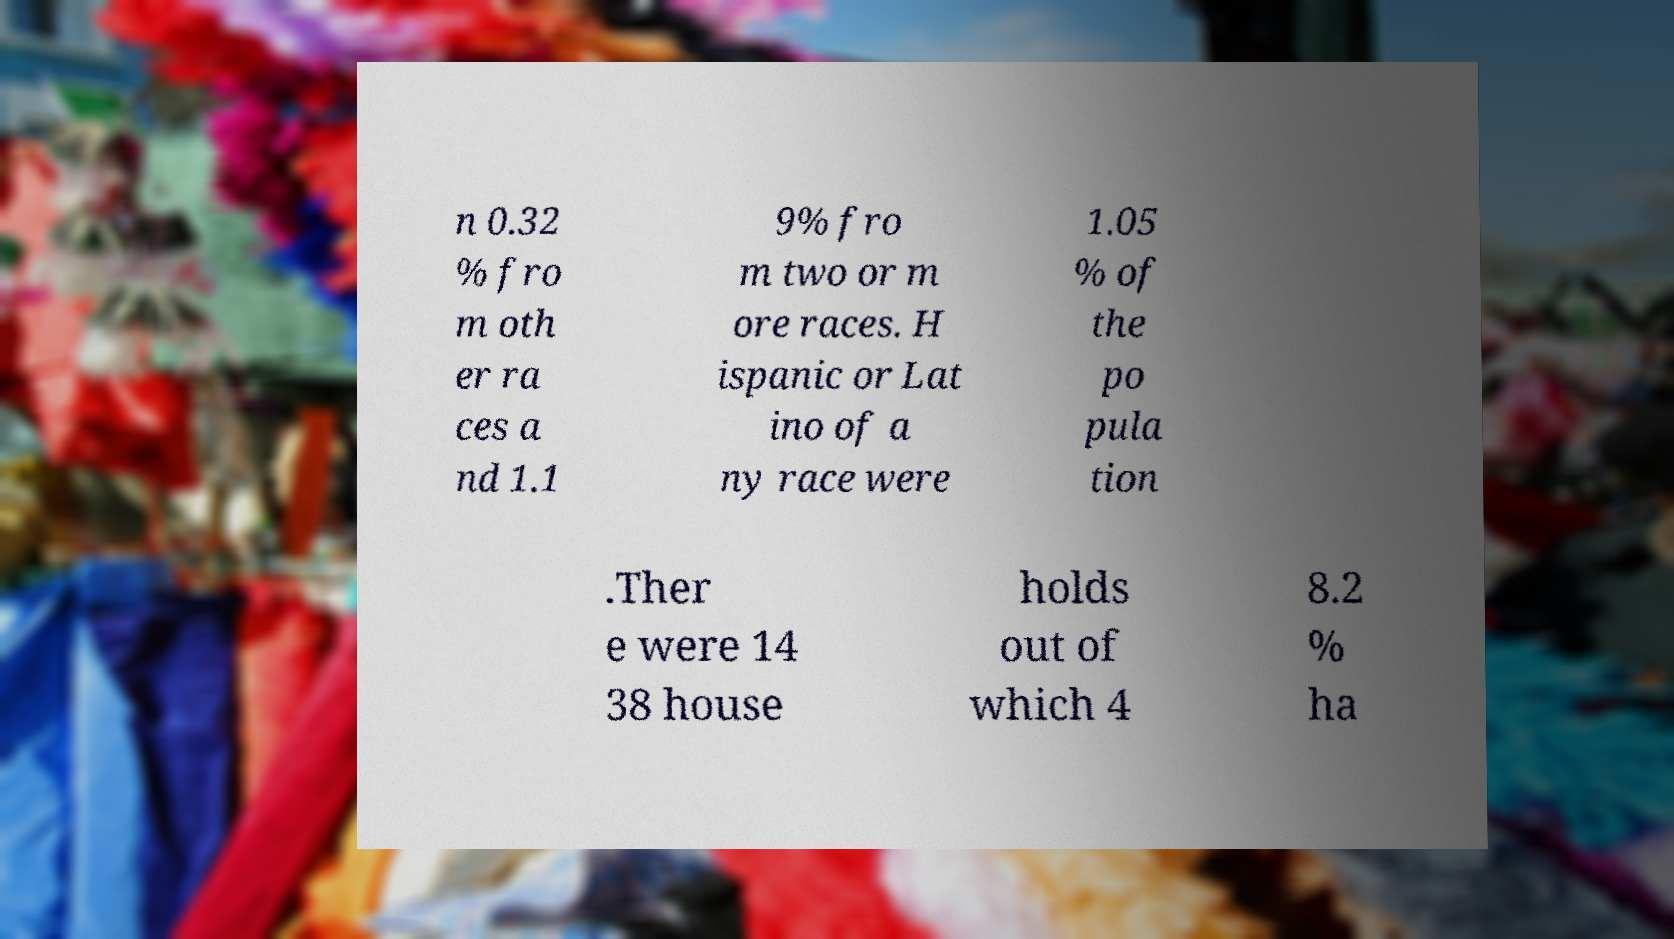Can you read and provide the text displayed in the image?This photo seems to have some interesting text. Can you extract and type it out for me? n 0.32 % fro m oth er ra ces a nd 1.1 9% fro m two or m ore races. H ispanic or Lat ino of a ny race were 1.05 % of the po pula tion .Ther e were 14 38 house holds out of which 4 8.2 % ha 